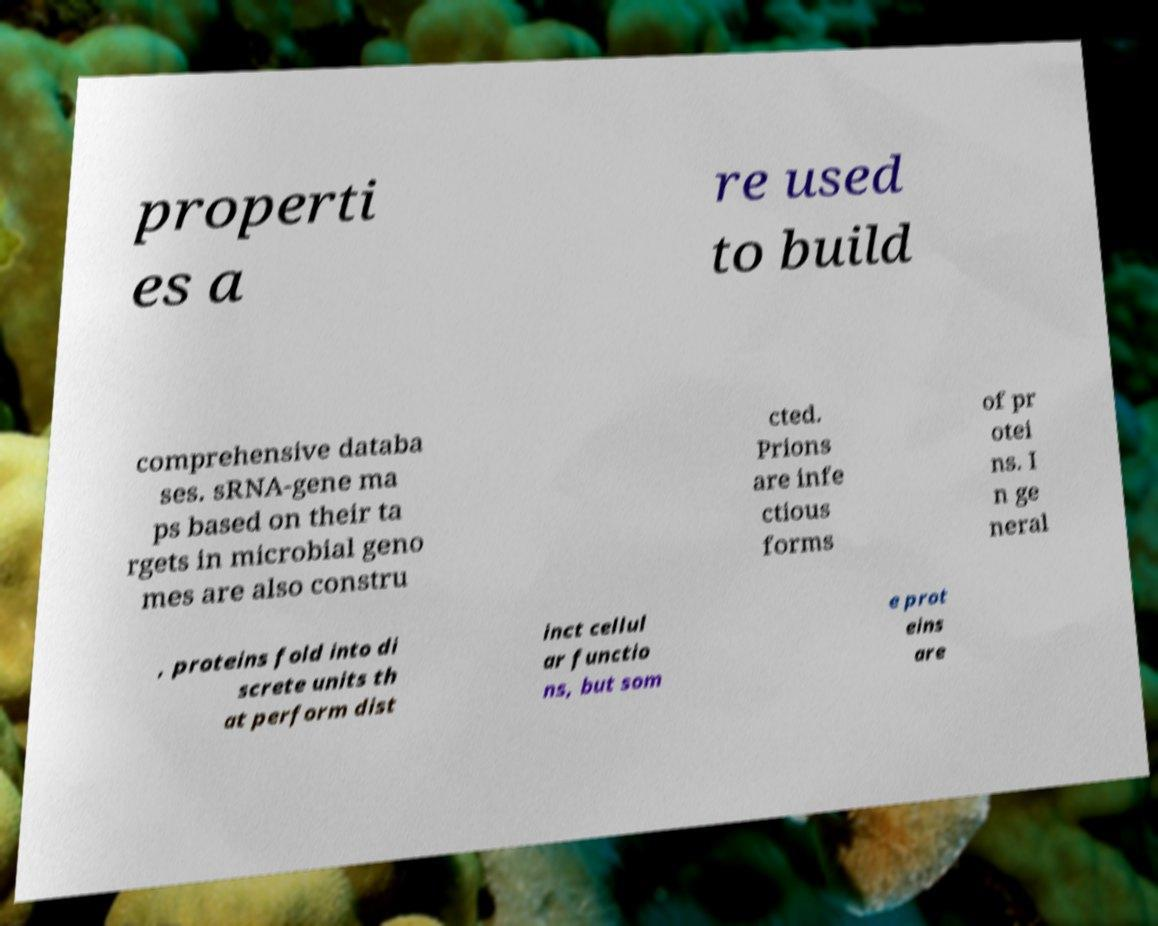For documentation purposes, I need the text within this image transcribed. Could you provide that? properti es a re used to build comprehensive databa ses. sRNA-gene ma ps based on their ta rgets in microbial geno mes are also constru cted. Prions are infe ctious forms of pr otei ns. I n ge neral , proteins fold into di screte units th at perform dist inct cellul ar functio ns, but som e prot eins are 